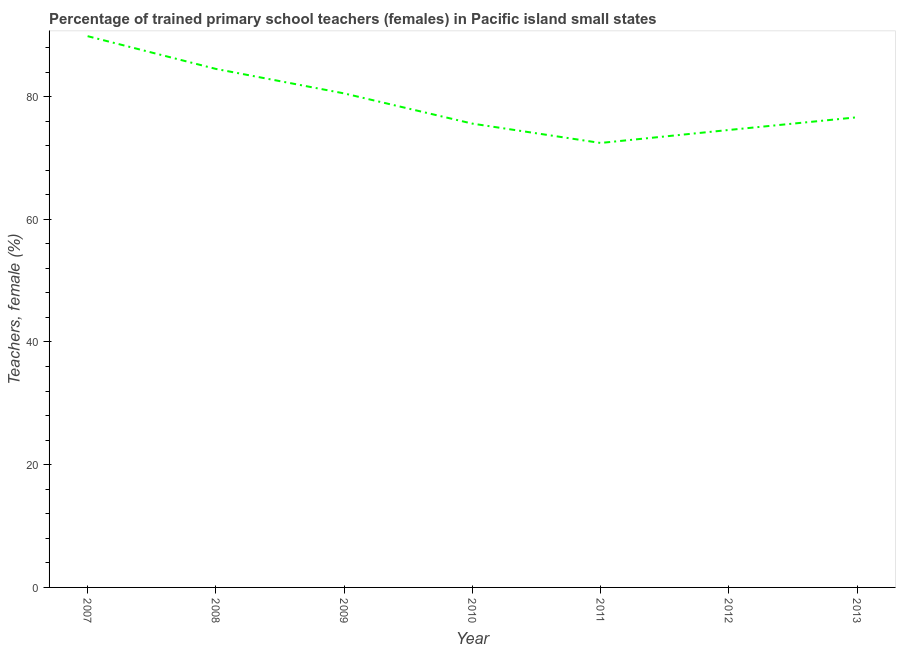What is the percentage of trained female teachers in 2011?
Offer a very short reply. 72.44. Across all years, what is the maximum percentage of trained female teachers?
Your answer should be very brief. 89.84. Across all years, what is the minimum percentage of trained female teachers?
Your answer should be very brief. 72.44. In which year was the percentage of trained female teachers maximum?
Offer a very short reply. 2007. In which year was the percentage of trained female teachers minimum?
Offer a terse response. 2011. What is the sum of the percentage of trained female teachers?
Provide a succinct answer. 554.08. What is the difference between the percentage of trained female teachers in 2008 and 2013?
Provide a succinct answer. 7.88. What is the average percentage of trained female teachers per year?
Your answer should be compact. 79.15. What is the median percentage of trained female teachers?
Give a very brief answer. 76.62. What is the ratio of the percentage of trained female teachers in 2008 to that in 2011?
Give a very brief answer. 1.17. Is the percentage of trained female teachers in 2008 less than that in 2010?
Your answer should be compact. No. Is the difference between the percentage of trained female teachers in 2008 and 2010 greater than the difference between any two years?
Your answer should be very brief. No. What is the difference between the highest and the second highest percentage of trained female teachers?
Offer a terse response. 5.34. What is the difference between the highest and the lowest percentage of trained female teachers?
Your answer should be very brief. 17.41. Does the percentage of trained female teachers monotonically increase over the years?
Give a very brief answer. No. How many years are there in the graph?
Keep it short and to the point. 7. Does the graph contain any zero values?
Your response must be concise. No. Does the graph contain grids?
Your answer should be compact. No. What is the title of the graph?
Your answer should be very brief. Percentage of trained primary school teachers (females) in Pacific island small states. What is the label or title of the Y-axis?
Ensure brevity in your answer.  Teachers, female (%). What is the Teachers, female (%) in 2007?
Give a very brief answer. 89.84. What is the Teachers, female (%) of 2008?
Provide a short and direct response. 84.51. What is the Teachers, female (%) in 2009?
Offer a very short reply. 80.52. What is the Teachers, female (%) of 2010?
Your answer should be compact. 75.59. What is the Teachers, female (%) of 2011?
Offer a terse response. 72.44. What is the Teachers, female (%) of 2012?
Provide a succinct answer. 74.55. What is the Teachers, female (%) of 2013?
Provide a short and direct response. 76.62. What is the difference between the Teachers, female (%) in 2007 and 2008?
Provide a short and direct response. 5.34. What is the difference between the Teachers, female (%) in 2007 and 2009?
Your response must be concise. 9.33. What is the difference between the Teachers, female (%) in 2007 and 2010?
Your answer should be very brief. 14.25. What is the difference between the Teachers, female (%) in 2007 and 2011?
Provide a short and direct response. 17.41. What is the difference between the Teachers, female (%) in 2007 and 2012?
Make the answer very short. 15.29. What is the difference between the Teachers, female (%) in 2007 and 2013?
Your answer should be compact. 13.22. What is the difference between the Teachers, female (%) in 2008 and 2009?
Keep it short and to the point. 3.99. What is the difference between the Teachers, female (%) in 2008 and 2010?
Ensure brevity in your answer.  8.92. What is the difference between the Teachers, female (%) in 2008 and 2011?
Offer a terse response. 12.07. What is the difference between the Teachers, female (%) in 2008 and 2012?
Provide a succinct answer. 9.95. What is the difference between the Teachers, female (%) in 2008 and 2013?
Offer a terse response. 7.88. What is the difference between the Teachers, female (%) in 2009 and 2010?
Ensure brevity in your answer.  4.93. What is the difference between the Teachers, female (%) in 2009 and 2011?
Make the answer very short. 8.08. What is the difference between the Teachers, female (%) in 2009 and 2012?
Offer a terse response. 5.96. What is the difference between the Teachers, female (%) in 2009 and 2013?
Provide a short and direct response. 3.89. What is the difference between the Teachers, female (%) in 2010 and 2011?
Provide a succinct answer. 3.15. What is the difference between the Teachers, female (%) in 2010 and 2012?
Your answer should be very brief. 1.04. What is the difference between the Teachers, female (%) in 2010 and 2013?
Your answer should be compact. -1.03. What is the difference between the Teachers, female (%) in 2011 and 2012?
Provide a short and direct response. -2.12. What is the difference between the Teachers, female (%) in 2011 and 2013?
Make the answer very short. -4.18. What is the difference between the Teachers, female (%) in 2012 and 2013?
Your answer should be very brief. -2.07. What is the ratio of the Teachers, female (%) in 2007 to that in 2008?
Make the answer very short. 1.06. What is the ratio of the Teachers, female (%) in 2007 to that in 2009?
Offer a terse response. 1.12. What is the ratio of the Teachers, female (%) in 2007 to that in 2010?
Provide a short and direct response. 1.19. What is the ratio of the Teachers, female (%) in 2007 to that in 2011?
Give a very brief answer. 1.24. What is the ratio of the Teachers, female (%) in 2007 to that in 2012?
Provide a short and direct response. 1.21. What is the ratio of the Teachers, female (%) in 2007 to that in 2013?
Your answer should be compact. 1.17. What is the ratio of the Teachers, female (%) in 2008 to that in 2009?
Ensure brevity in your answer.  1.05. What is the ratio of the Teachers, female (%) in 2008 to that in 2010?
Keep it short and to the point. 1.12. What is the ratio of the Teachers, female (%) in 2008 to that in 2011?
Your answer should be compact. 1.17. What is the ratio of the Teachers, female (%) in 2008 to that in 2012?
Keep it short and to the point. 1.13. What is the ratio of the Teachers, female (%) in 2008 to that in 2013?
Offer a terse response. 1.1. What is the ratio of the Teachers, female (%) in 2009 to that in 2010?
Provide a short and direct response. 1.06. What is the ratio of the Teachers, female (%) in 2009 to that in 2011?
Your answer should be very brief. 1.11. What is the ratio of the Teachers, female (%) in 2009 to that in 2012?
Make the answer very short. 1.08. What is the ratio of the Teachers, female (%) in 2009 to that in 2013?
Your response must be concise. 1.05. What is the ratio of the Teachers, female (%) in 2010 to that in 2011?
Your response must be concise. 1.04. What is the ratio of the Teachers, female (%) in 2010 to that in 2012?
Make the answer very short. 1.01. What is the ratio of the Teachers, female (%) in 2011 to that in 2013?
Give a very brief answer. 0.94. What is the ratio of the Teachers, female (%) in 2012 to that in 2013?
Provide a succinct answer. 0.97. 